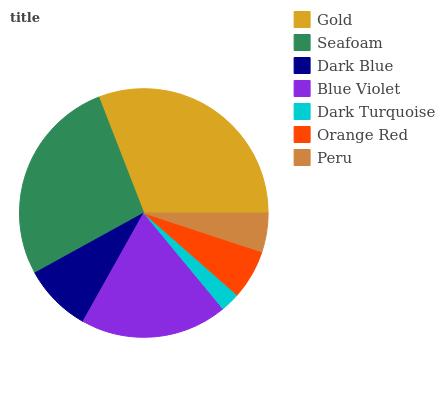Is Dark Turquoise the minimum?
Answer yes or no. Yes. Is Gold the maximum?
Answer yes or no. Yes. Is Seafoam the minimum?
Answer yes or no. No. Is Seafoam the maximum?
Answer yes or no. No. Is Gold greater than Seafoam?
Answer yes or no. Yes. Is Seafoam less than Gold?
Answer yes or no. Yes. Is Seafoam greater than Gold?
Answer yes or no. No. Is Gold less than Seafoam?
Answer yes or no. No. Is Dark Blue the high median?
Answer yes or no. Yes. Is Dark Blue the low median?
Answer yes or no. Yes. Is Blue Violet the high median?
Answer yes or no. No. Is Gold the low median?
Answer yes or no. No. 